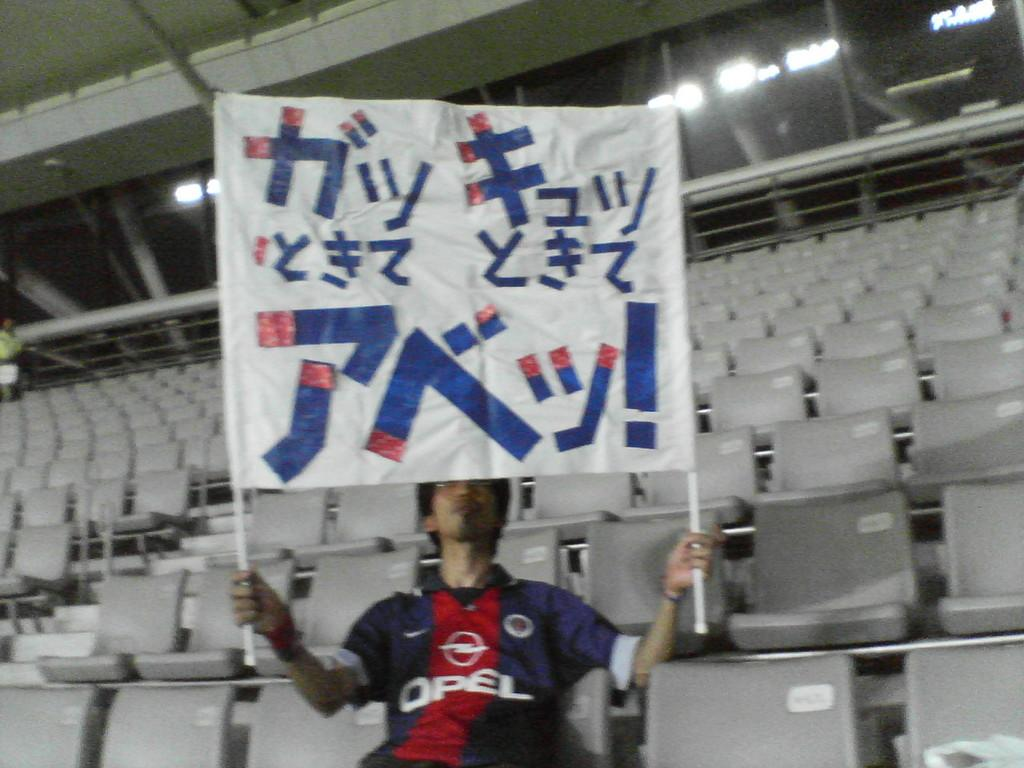Provide a one-sentence caption for the provided image. A fan wearing a blue and red Opel shirt holds a banner. 